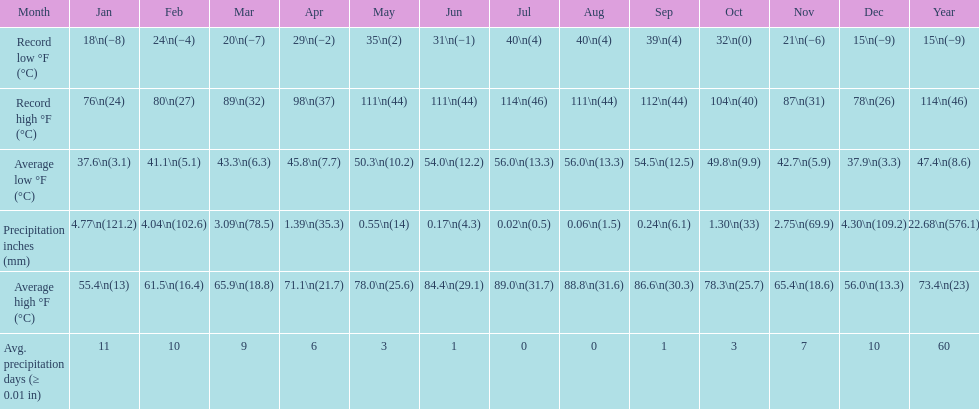Could you parse the entire table? {'header': ['Month', 'Jan', 'Feb', 'Mar', 'Apr', 'May', 'Jun', 'Jul', 'Aug', 'Sep', 'Oct', 'Nov', 'Dec', 'Year'], 'rows': [['Record low °F (°C)', '18\\n(−8)', '24\\n(−4)', '20\\n(−7)', '29\\n(−2)', '35\\n(2)', '31\\n(−1)', '40\\n(4)', '40\\n(4)', '39\\n(4)', '32\\n(0)', '21\\n(−6)', '15\\n(−9)', '15\\n(−9)'], ['Record high °F (°C)', '76\\n(24)', '80\\n(27)', '89\\n(32)', '98\\n(37)', '111\\n(44)', '111\\n(44)', '114\\n(46)', '111\\n(44)', '112\\n(44)', '104\\n(40)', '87\\n(31)', '78\\n(26)', '114\\n(46)'], ['Average low °F (°C)', '37.6\\n(3.1)', '41.1\\n(5.1)', '43.3\\n(6.3)', '45.8\\n(7.7)', '50.3\\n(10.2)', '54.0\\n(12.2)', '56.0\\n(13.3)', '56.0\\n(13.3)', '54.5\\n(12.5)', '49.8\\n(9.9)', '42.7\\n(5.9)', '37.9\\n(3.3)', '47.4\\n(8.6)'], ['Precipitation inches (mm)', '4.77\\n(121.2)', '4.04\\n(102.6)', '3.09\\n(78.5)', '1.39\\n(35.3)', '0.55\\n(14)', '0.17\\n(4.3)', '0.02\\n(0.5)', '0.06\\n(1.5)', '0.24\\n(6.1)', '1.30\\n(33)', '2.75\\n(69.9)', '4.30\\n(109.2)', '22.68\\n(576.1)'], ['Average high °F (°C)', '55.4\\n(13)', '61.5\\n(16.4)', '65.9\\n(18.8)', '71.1\\n(21.7)', '78.0\\n(25.6)', '84.4\\n(29.1)', '89.0\\n(31.7)', '88.8\\n(31.6)', '86.6\\n(30.3)', '78.3\\n(25.7)', '65.4\\n(18.6)', '56.0\\n(13.3)', '73.4\\n(23)'], ['Avg. precipitation days (≥ 0.01 in)', '11', '10', '9', '6', '3', '1', '0', '0', '1', '3', '7', '10', '60']]} Which month had an average high of 89.0 degrees and an average low of 56.0 degrees? July. 